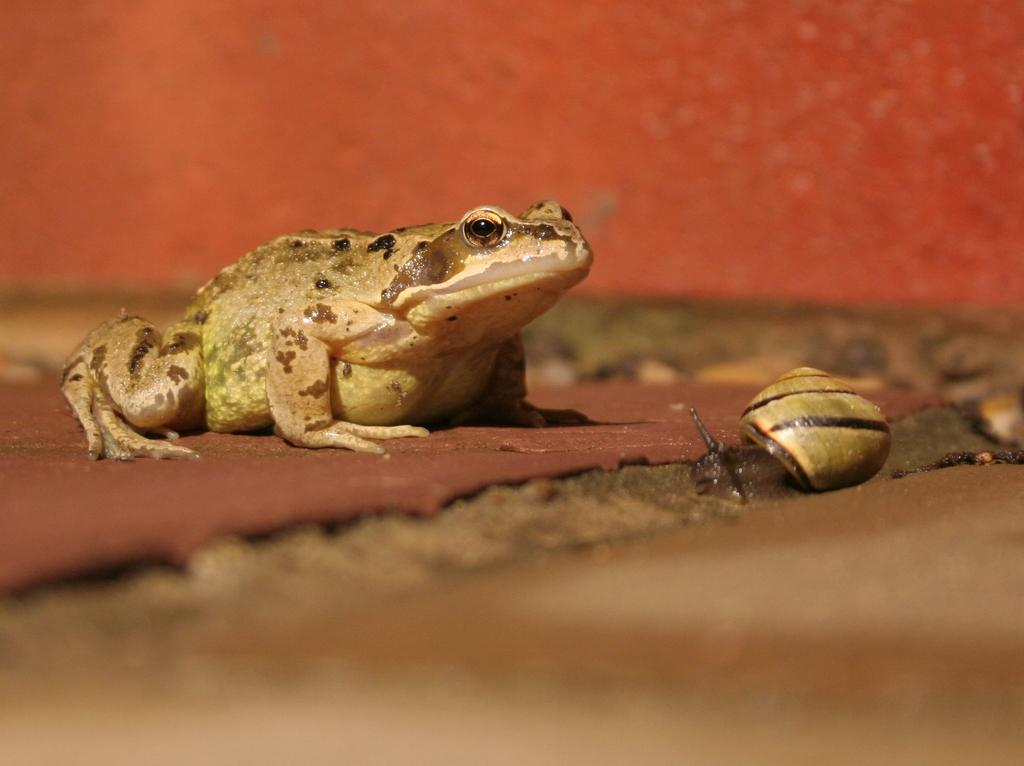What type of animal is located on the left side of the image? There is a frog on the left side of the image. What other animal can be seen on the right side of the image? There is a snail on the right side of the image. What is visible at the bottom of the image? The ground is visible at the bottom of the image. What type of chair is visible in the image? There is no chair present in the image. What kind of wood can be seen in the image? There is no wood visible in the image. 